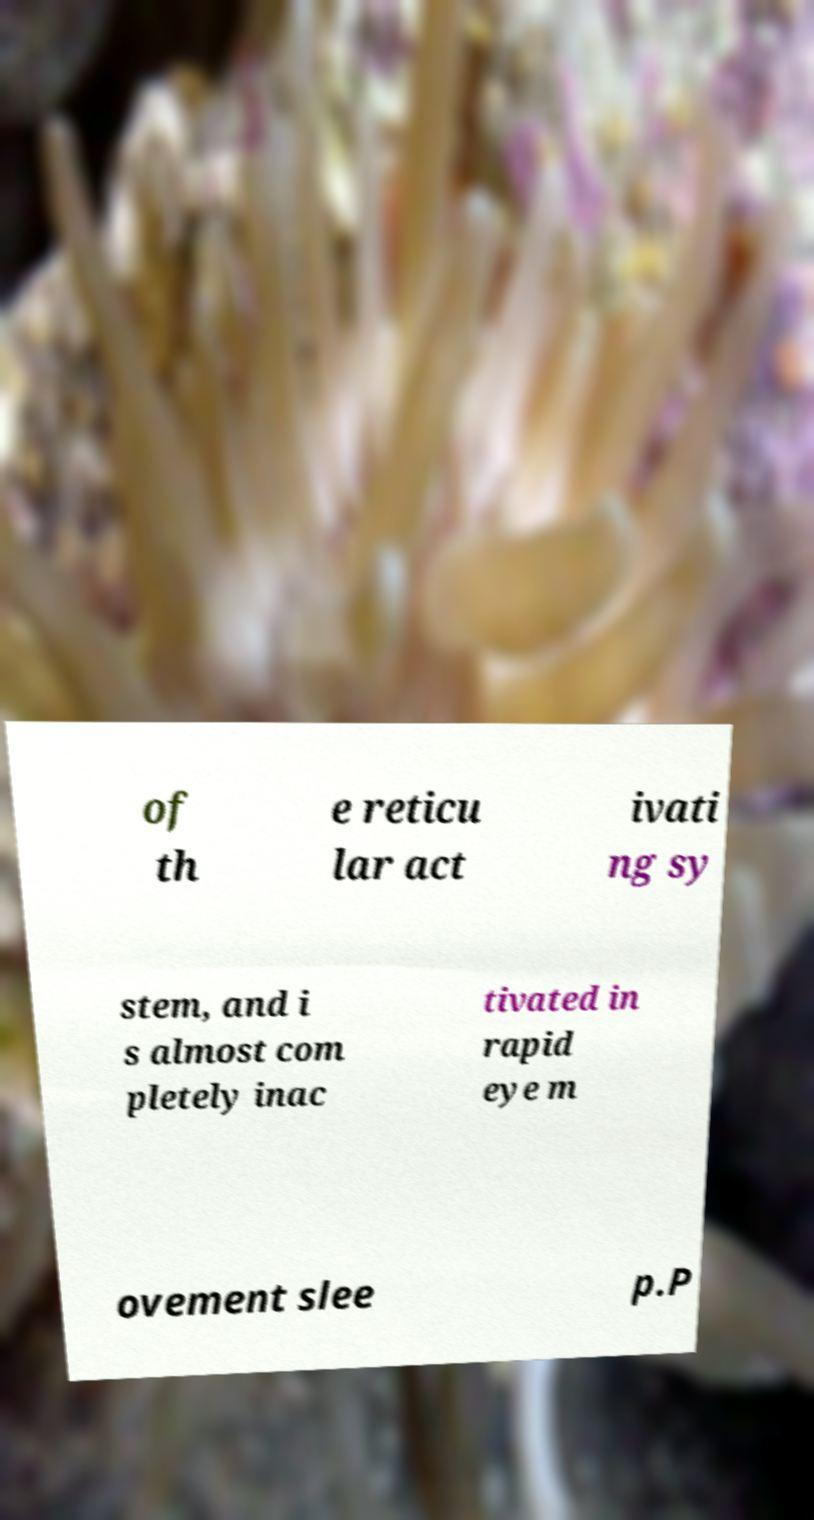Can you read and provide the text displayed in the image?This photo seems to have some interesting text. Can you extract and type it out for me? of th e reticu lar act ivati ng sy stem, and i s almost com pletely inac tivated in rapid eye m ovement slee p.P 